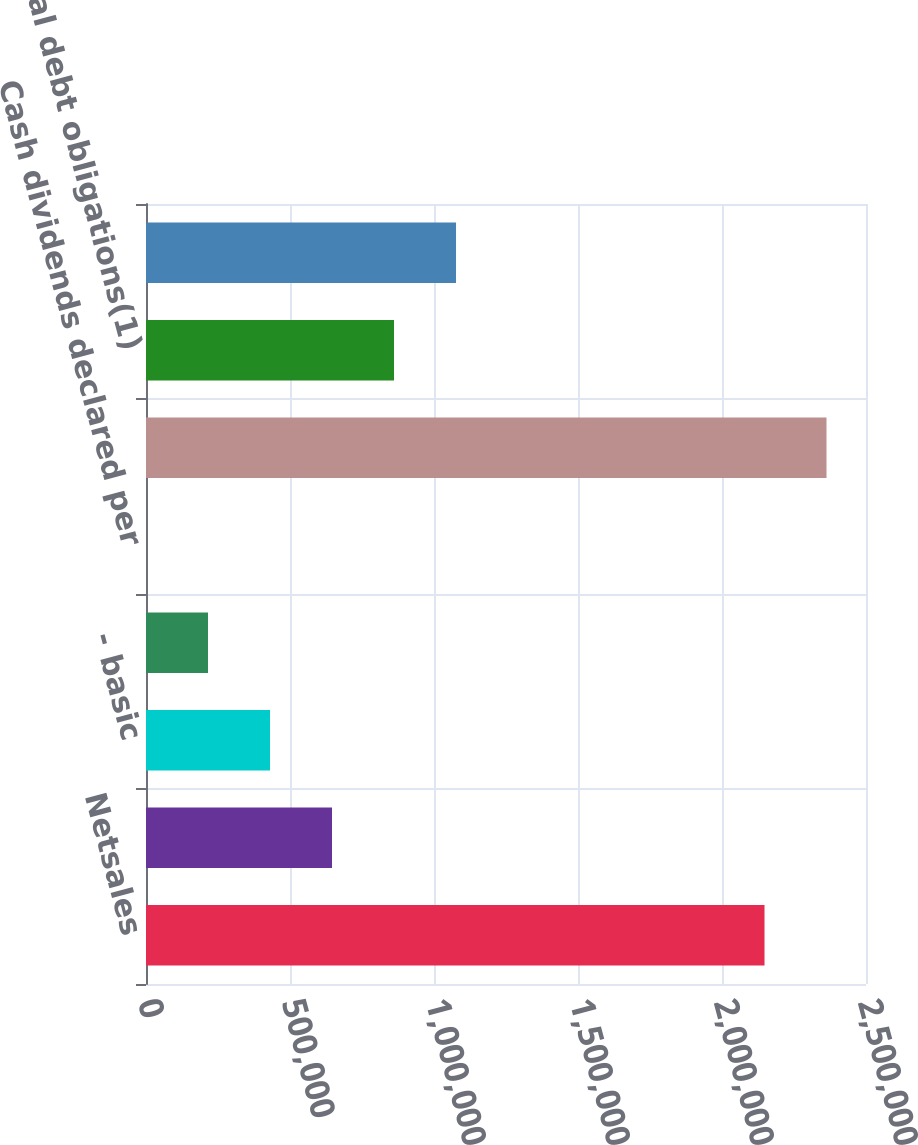Convert chart. <chart><loc_0><loc_0><loc_500><loc_500><bar_chart><fcel>Netsales<fcel>Net income<fcel>- basic<fcel>-diluted<fcel>Cash dividends declared per<fcel>Total assets<fcel>Total debt obligations(1)<fcel>Stockholders' equity<nl><fcel>2.14759e+06<fcel>645852<fcel>430568<fcel>215285<fcel>0.6<fcel>2.36287e+06<fcel>861136<fcel>1.07642e+06<nl></chart> 